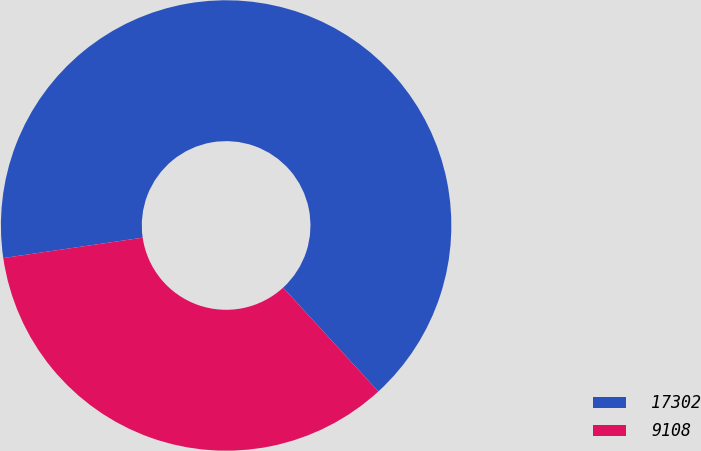<chart> <loc_0><loc_0><loc_500><loc_500><pie_chart><fcel>17302<fcel>9108<nl><fcel>65.5%<fcel>34.5%<nl></chart> 